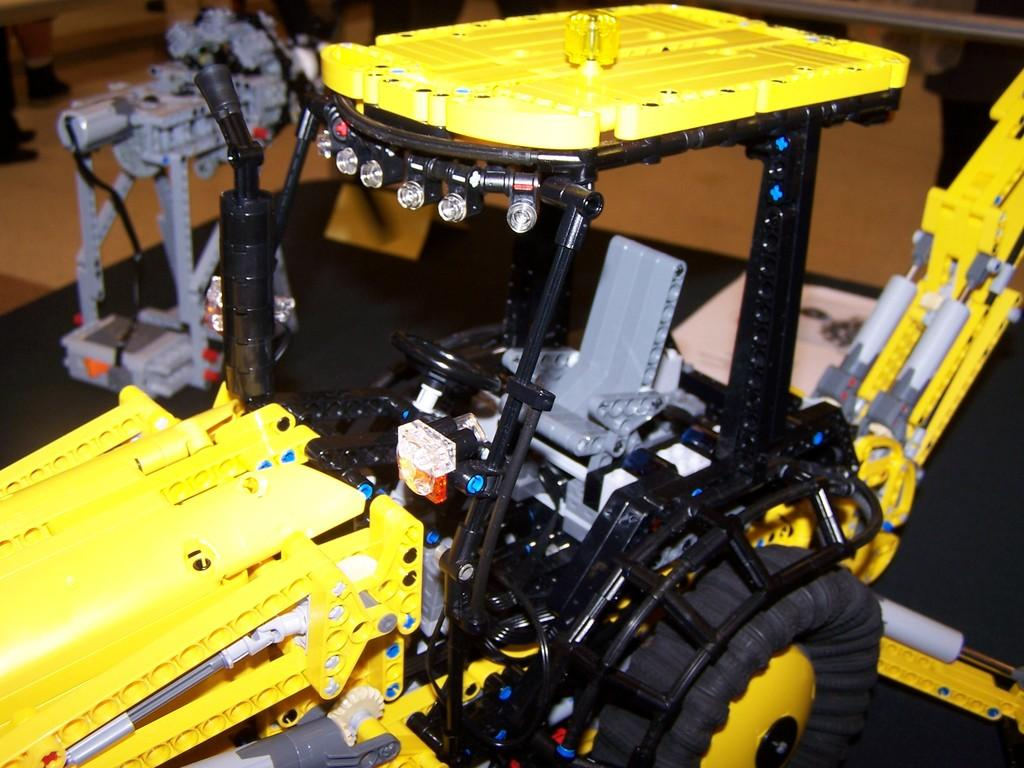What type of object is in the image? There is a toy vehicle in the image. What color is the toy vehicle? The toy vehicle is yellow in color. Is there a stream of beans flowing from the toy vehicle in the image? No, there is no stream of beans or any other substance flowing from the toy vehicle in the image. 